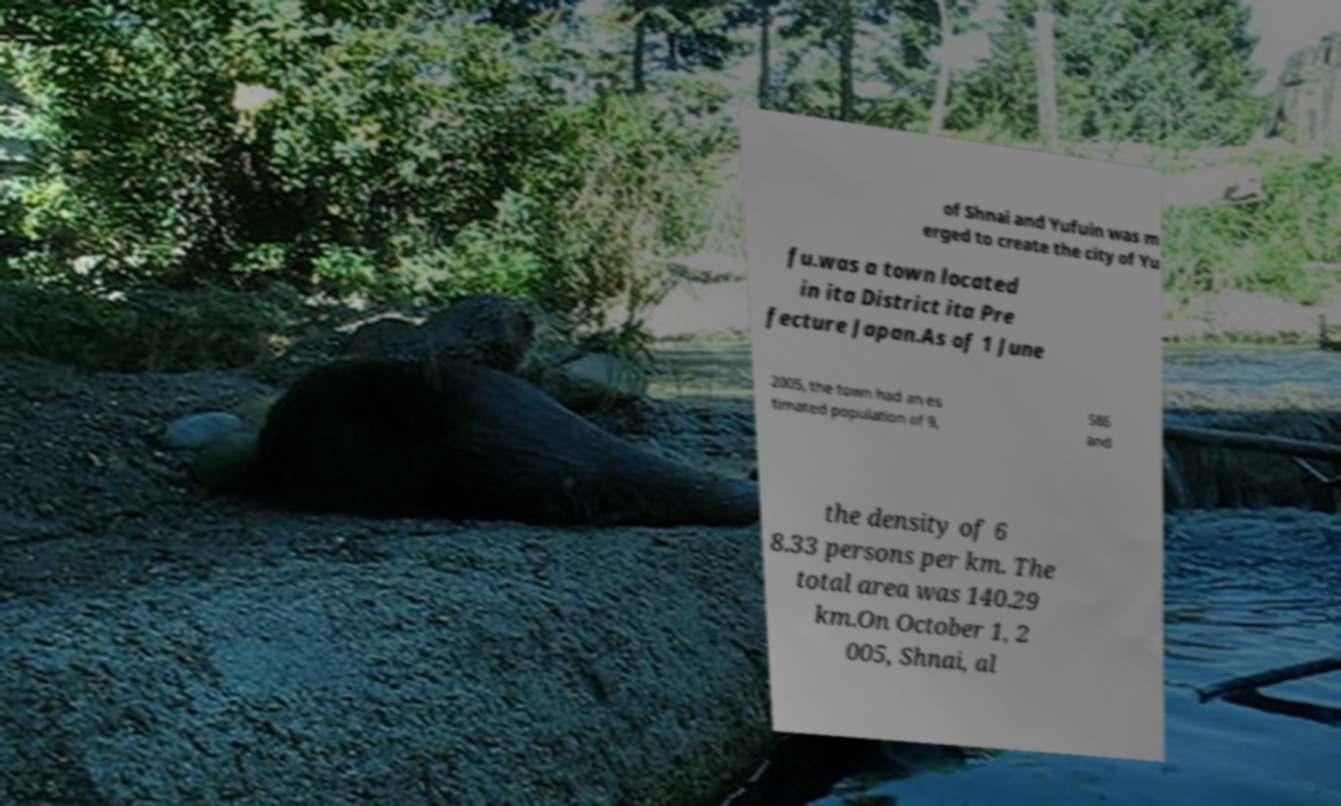I need the written content from this picture converted into text. Can you do that? of Shnai and Yufuin was m erged to create the city of Yu fu.was a town located in ita District ita Pre fecture Japan.As of 1 June 2005, the town had an es timated population of 9, 586 and the density of 6 8.33 persons per km. The total area was 140.29 km.On October 1, 2 005, Shnai, al 